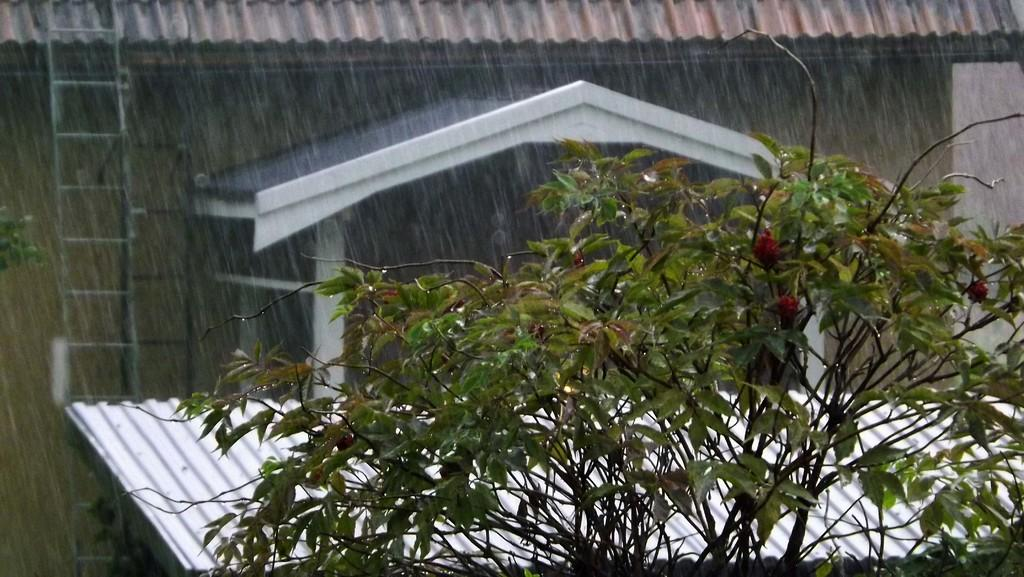What type of plant is visible in the image? There is a plant with flowers in the image. What type of structure can be seen in the image? There is a house in the image. What objects are used for climbing or reaching high places in the image? There are ladders in the image. What material is the sheet-like object in the image made of? There is a metal sheet in the image. What weather condition is occurring in the image? A: It is raining in the image. Can you see a trail of needles leading to the house in the image? There is no trail of needles present in the image. 